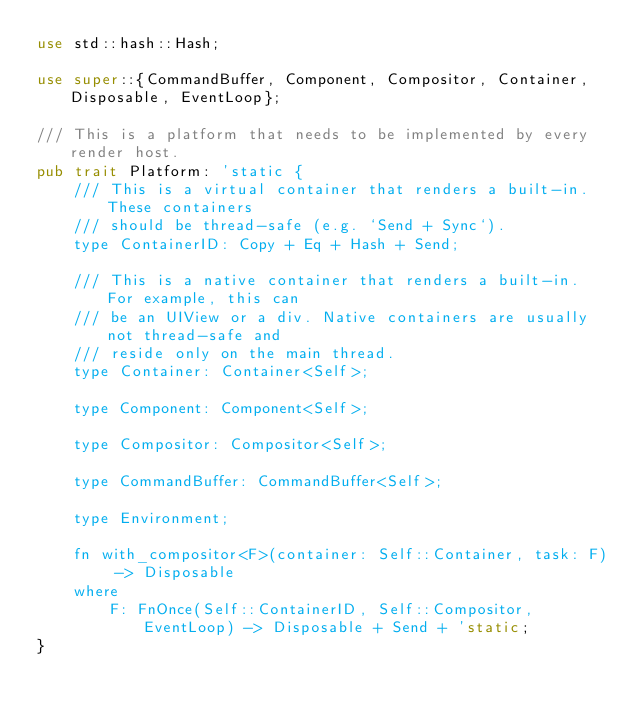Convert code to text. <code><loc_0><loc_0><loc_500><loc_500><_Rust_>use std::hash::Hash;

use super::{CommandBuffer, Component, Compositor, Container, Disposable, EventLoop};

/// This is a platform that needs to be implemented by every render host.
pub trait Platform: 'static {
    /// This is a virtual container that renders a built-in. These containers
    /// should be thread-safe (e.g. `Send + Sync`).
    type ContainerID: Copy + Eq + Hash + Send;

    /// This is a native container that renders a built-in. For example, this can
    /// be an UIView or a div. Native containers are usually not thread-safe and
    /// reside only on the main thread.
    type Container: Container<Self>;

    type Component: Component<Self>;

    type Compositor: Compositor<Self>;

    type CommandBuffer: CommandBuffer<Self>;

    type Environment;

    fn with_compositor<F>(container: Self::Container, task: F) -> Disposable
    where
        F: FnOnce(Self::ContainerID, Self::Compositor, EventLoop) -> Disposable + Send + 'static;
}
</code> 